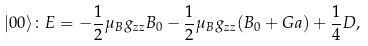Convert formula to latex. <formula><loc_0><loc_0><loc_500><loc_500>| 0 0 \rangle \colon E = - \frac { 1 } { 2 } \mu _ { B } g _ { z z } B _ { 0 } - \frac { 1 } { 2 } \mu _ { B } g _ { z z } ( B _ { 0 } + G a ) + \frac { 1 } { 4 } D ,</formula> 